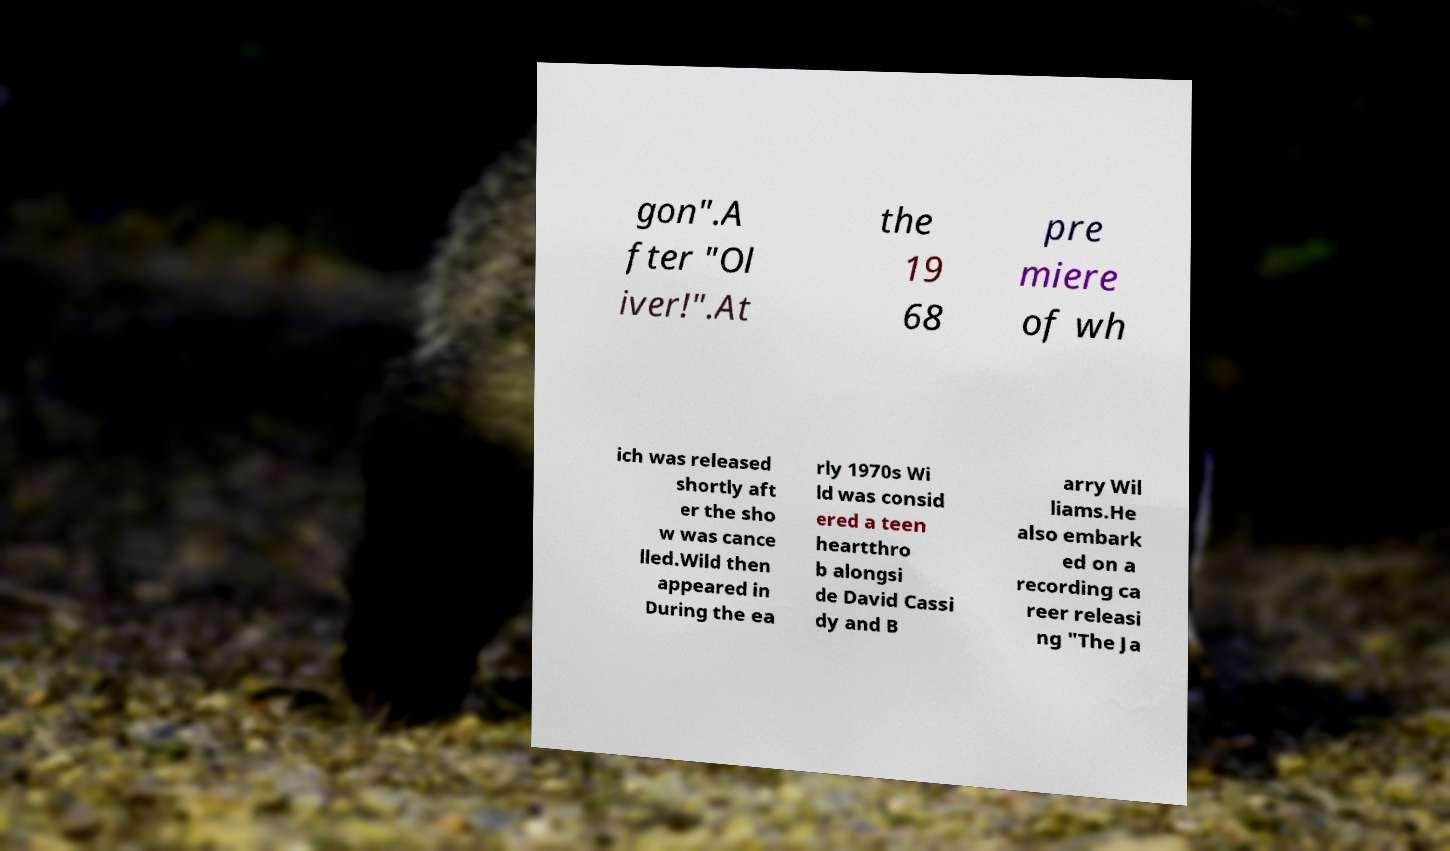For documentation purposes, I need the text within this image transcribed. Could you provide that? gon".A fter "Ol iver!".At the 19 68 pre miere of wh ich was released shortly aft er the sho w was cance lled.Wild then appeared in During the ea rly 1970s Wi ld was consid ered a teen heartthro b alongsi de David Cassi dy and B arry Wil liams.He also embark ed on a recording ca reer releasi ng "The Ja 